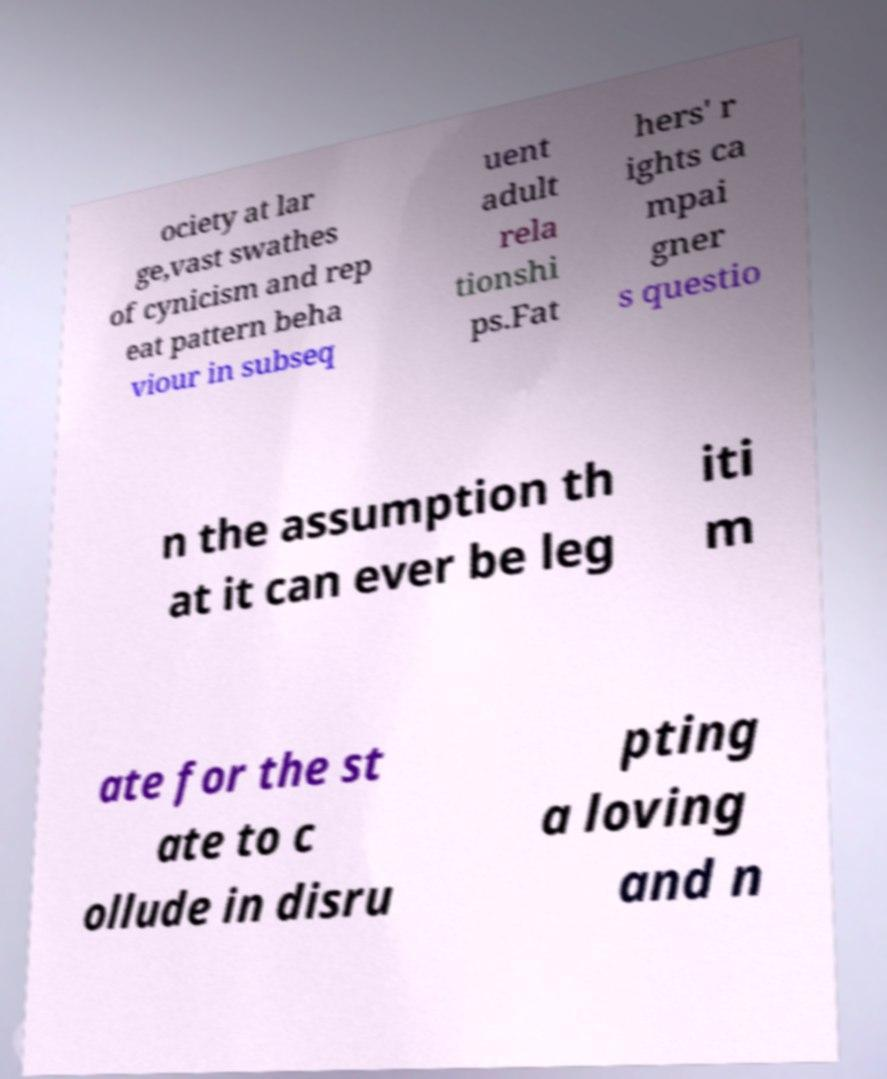There's text embedded in this image that I need extracted. Can you transcribe it verbatim? ociety at lar ge,vast swathes of cynicism and rep eat pattern beha viour in subseq uent adult rela tionshi ps.Fat hers' r ights ca mpai gner s questio n the assumption th at it can ever be leg iti m ate for the st ate to c ollude in disru pting a loving and n 